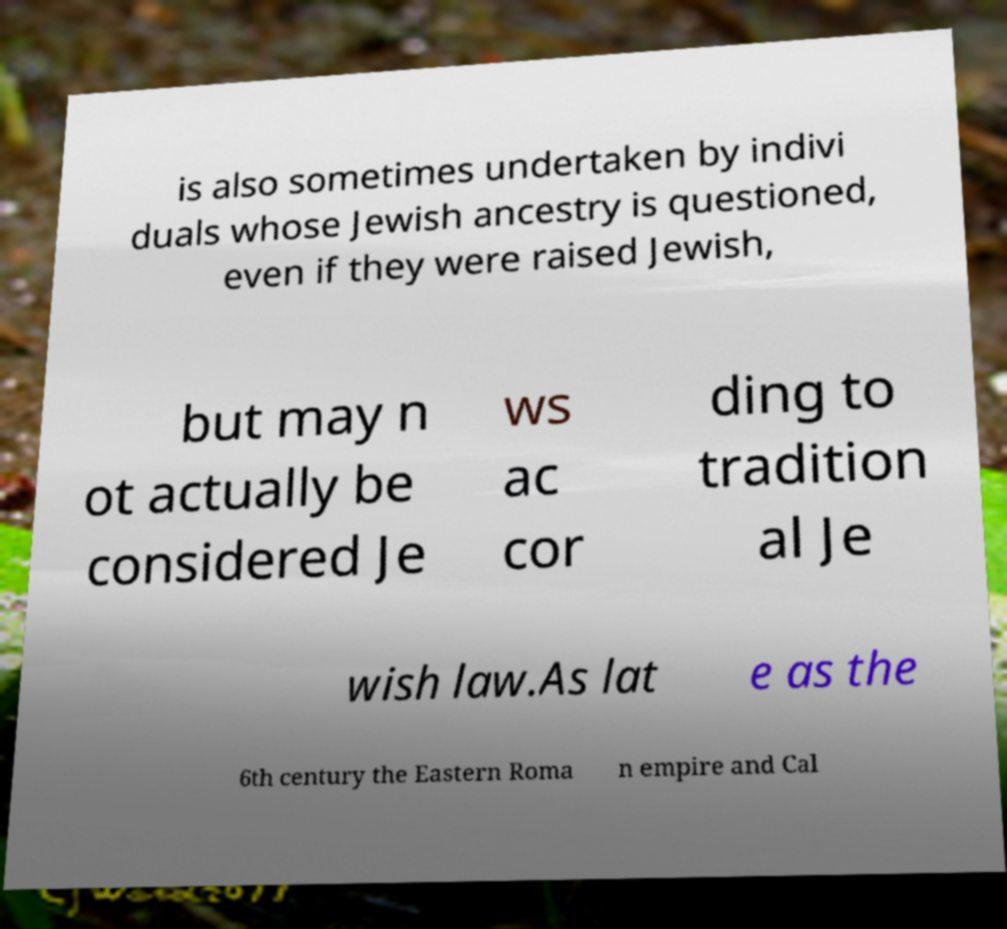Could you assist in decoding the text presented in this image and type it out clearly? is also sometimes undertaken by indivi duals whose Jewish ancestry is questioned, even if they were raised Jewish, but may n ot actually be considered Je ws ac cor ding to tradition al Je wish law.As lat e as the 6th century the Eastern Roma n empire and Cal 